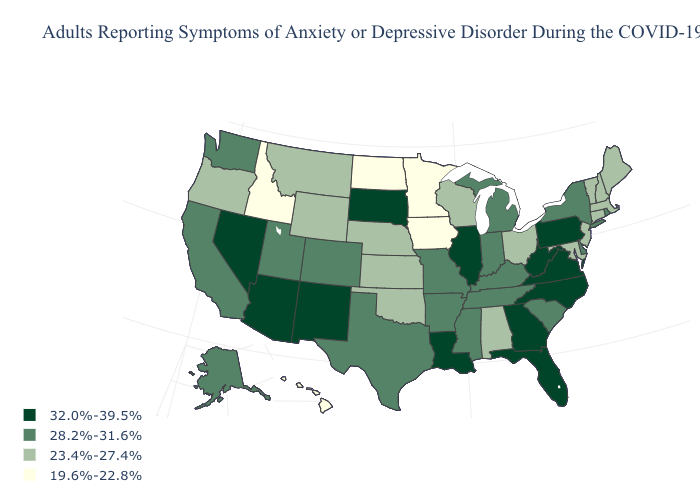Name the states that have a value in the range 19.6%-22.8%?
Keep it brief. Hawaii, Idaho, Iowa, Minnesota, North Dakota. Does the first symbol in the legend represent the smallest category?
Give a very brief answer. No. Does Maryland have the lowest value in the USA?
Concise answer only. No. What is the value of North Carolina?
Answer briefly. 32.0%-39.5%. Is the legend a continuous bar?
Give a very brief answer. No. What is the value of Massachusetts?
Short answer required. 23.4%-27.4%. Name the states that have a value in the range 32.0%-39.5%?
Write a very short answer. Arizona, Florida, Georgia, Illinois, Louisiana, Nevada, New Mexico, North Carolina, Pennsylvania, South Dakota, Virginia, West Virginia. Is the legend a continuous bar?
Short answer required. No. Name the states that have a value in the range 23.4%-27.4%?
Keep it brief. Alabama, Connecticut, Kansas, Maine, Maryland, Massachusetts, Montana, Nebraska, New Hampshire, New Jersey, Ohio, Oklahoma, Oregon, Vermont, Wisconsin, Wyoming. What is the value of Maine?
Short answer required. 23.4%-27.4%. Name the states that have a value in the range 23.4%-27.4%?
Concise answer only. Alabama, Connecticut, Kansas, Maine, Maryland, Massachusetts, Montana, Nebraska, New Hampshire, New Jersey, Ohio, Oklahoma, Oregon, Vermont, Wisconsin, Wyoming. What is the value of Mississippi?
Concise answer only. 28.2%-31.6%. What is the value of Pennsylvania?
Be succinct. 32.0%-39.5%. Among the states that border Wisconsin , which have the lowest value?
Quick response, please. Iowa, Minnesota. Name the states that have a value in the range 28.2%-31.6%?
Give a very brief answer. Alaska, Arkansas, California, Colorado, Delaware, Indiana, Kentucky, Michigan, Mississippi, Missouri, New York, Rhode Island, South Carolina, Tennessee, Texas, Utah, Washington. 